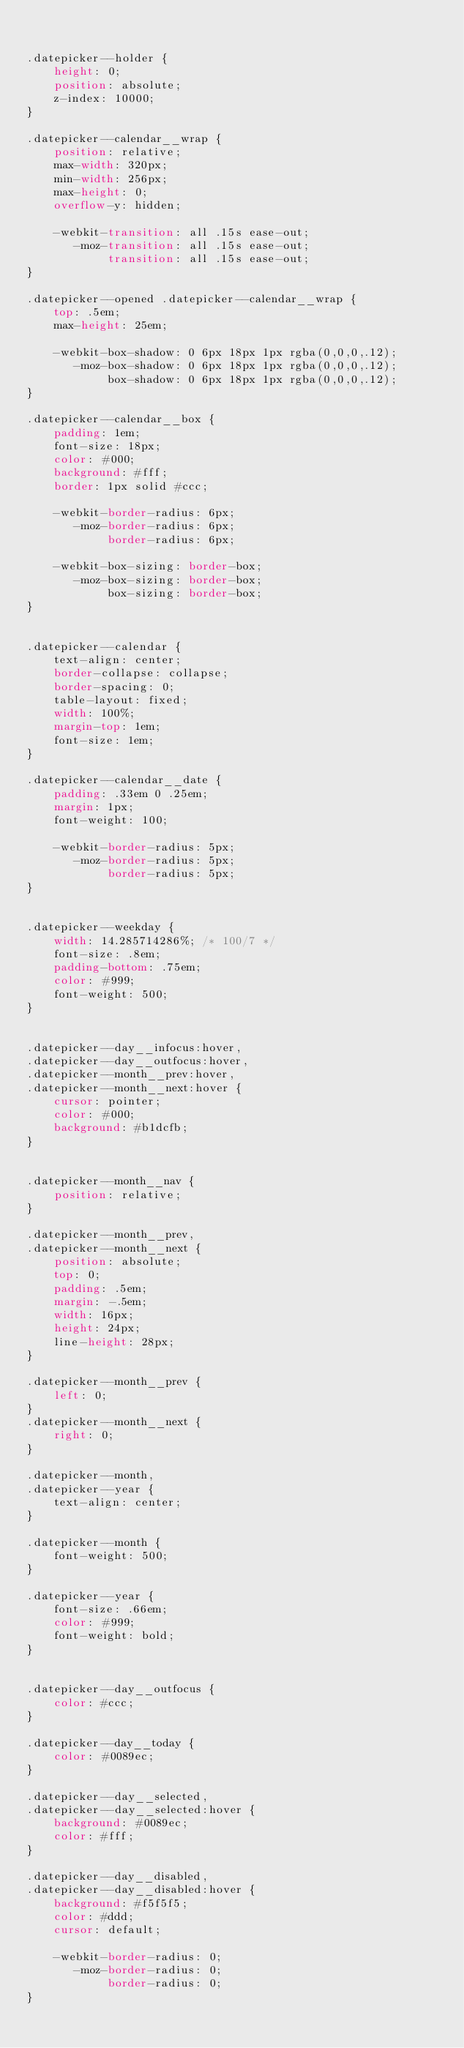<code> <loc_0><loc_0><loc_500><loc_500><_CSS_>

.datepicker--holder {
    height: 0;
    position: absolute;
    z-index: 10000;
}

.datepicker--calendar__wrap {
    position: relative;
    max-width: 320px;
    min-width: 256px;
    max-height: 0;
    overflow-y: hidden;

    -webkit-transition: all .15s ease-out;
       -moz-transition: all .15s ease-out;
            transition: all .15s ease-out;
}

.datepicker--opened .datepicker--calendar__wrap {
    top: .5em;
    max-height: 25em;

    -webkit-box-shadow: 0 6px 18px 1px rgba(0,0,0,.12);
       -moz-box-shadow: 0 6px 18px 1px rgba(0,0,0,.12);
            box-shadow: 0 6px 18px 1px rgba(0,0,0,.12);
}

.datepicker--calendar__box {
    padding: 1em;
    font-size: 18px;
    color: #000;
    background: #fff;
    border: 1px solid #ccc;

    -webkit-border-radius: 6px;
       -moz-border-radius: 6px;
            border-radius: 6px;

    -webkit-box-sizing: border-box;
       -moz-box-sizing: border-box;
            box-sizing: border-box;
}


.datepicker--calendar {
    text-align: center;
    border-collapse: collapse;
    border-spacing: 0;
    table-layout: fixed;
    width: 100%;
    margin-top: 1em;
    font-size: 1em;
}

.datepicker--calendar__date {
    padding: .33em 0 .25em;
    margin: 1px;
    font-weight: 100;

    -webkit-border-radius: 5px;
       -moz-border-radius: 5px;
            border-radius: 5px;
}


.datepicker--weekday {
    width: 14.285714286%; /* 100/7 */
    font-size: .8em;
    padding-bottom: .75em;
    color: #999;
    font-weight: 500;
}


.datepicker--day__infocus:hover,
.datepicker--day__outfocus:hover,
.datepicker--month__prev:hover,
.datepicker--month__next:hover {
    cursor: pointer;
    color: #000;
    background: #b1dcfb;
}


.datepicker--month__nav {
    position: relative;
}

.datepicker--month__prev,
.datepicker--month__next {
    position: absolute;
    top: 0;
    padding: .5em;
    margin: -.5em;
    width: 16px;
    height: 24px;
    line-height: 28px;
}

.datepicker--month__prev {
    left: 0;
}
.datepicker--month__next {
    right: 0;
}

.datepicker--month,
.datepicker--year {
    text-align: center;
}

.datepicker--month {
    font-weight: 500;
}

.datepicker--year {
    font-size: .66em;
    color: #999;
    font-weight: bold;
}


.datepicker--day__outfocus {
    color: #ccc;
}

.datepicker--day__today {
    color: #0089ec;
}

.datepicker--day__selected,
.datepicker--day__selected:hover {
    background: #0089ec;
    color: #fff;
}

.datepicker--day__disabled,
.datepicker--day__disabled:hover {
    background: #f5f5f5;
    color: #ddd;
    cursor: default;

    -webkit-border-radius: 0;
       -moz-border-radius: 0;
            border-radius: 0;
}







</code> 